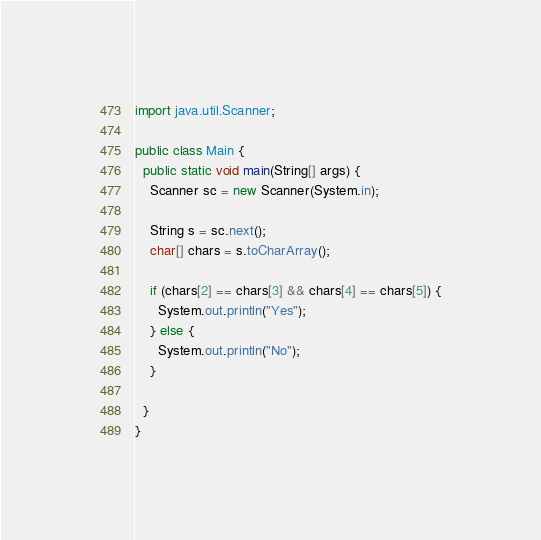<code> <loc_0><loc_0><loc_500><loc_500><_Java_>import java.util.Scanner;

public class Main {
  public static void main(String[] args) {
    Scanner sc = new Scanner(System.in);

    String s = sc.next();
    char[] chars = s.toCharArray();

    if (chars[2] == chars[3] && chars[4] == chars[5]) {
      System.out.println("Yes");
    } else {
      System.out.println("No");
    }

  }
}
</code> 